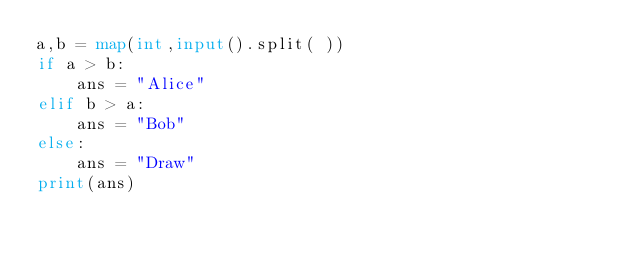<code> <loc_0><loc_0><loc_500><loc_500><_Python_>a,b = map(int,input().split( ))
if a > b:
	ans = "Alice"
elif b > a:
	ans = "Bob"
else:
	ans = "Draw"
print(ans)</code> 